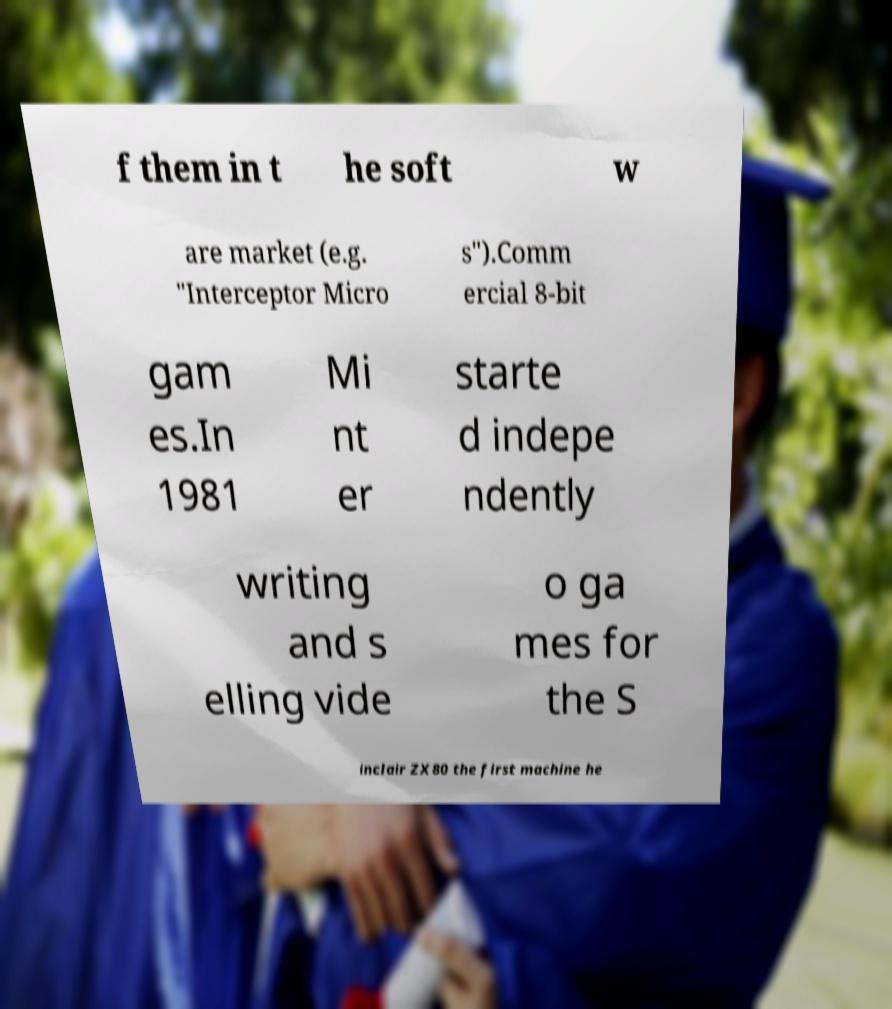Can you accurately transcribe the text from the provided image for me? f them in t he soft w are market (e.g. "Interceptor Micro s").Comm ercial 8-bit gam es.In 1981 Mi nt er starte d indepe ndently writing and s elling vide o ga mes for the S inclair ZX80 the first machine he 